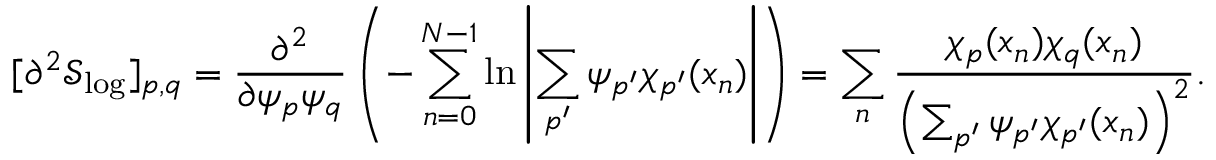Convert formula to latex. <formula><loc_0><loc_0><loc_500><loc_500>[ \partial ^ { 2 } \mathcal { S } _ { \log } ] _ { p , q } = \frac { \partial ^ { 2 } } { \partial \psi _ { p } \psi _ { q } } \left ( - \sum _ { n = 0 } ^ { N - 1 } \ln \left | \sum _ { p ^ { \prime } } \psi _ { p ^ { \prime } } \chi _ { p ^ { \prime } } ( x _ { n } ) \right | \right ) = \sum _ { n } \frac { \chi _ { p } ( x _ { n } ) \chi _ { q } ( x _ { n } ) } { \left ( \sum _ { p ^ { \prime } } \psi _ { p ^ { \prime } } \chi _ { p ^ { \prime } } ( x _ { n } ) \right ) ^ { 2 } } .</formula> 